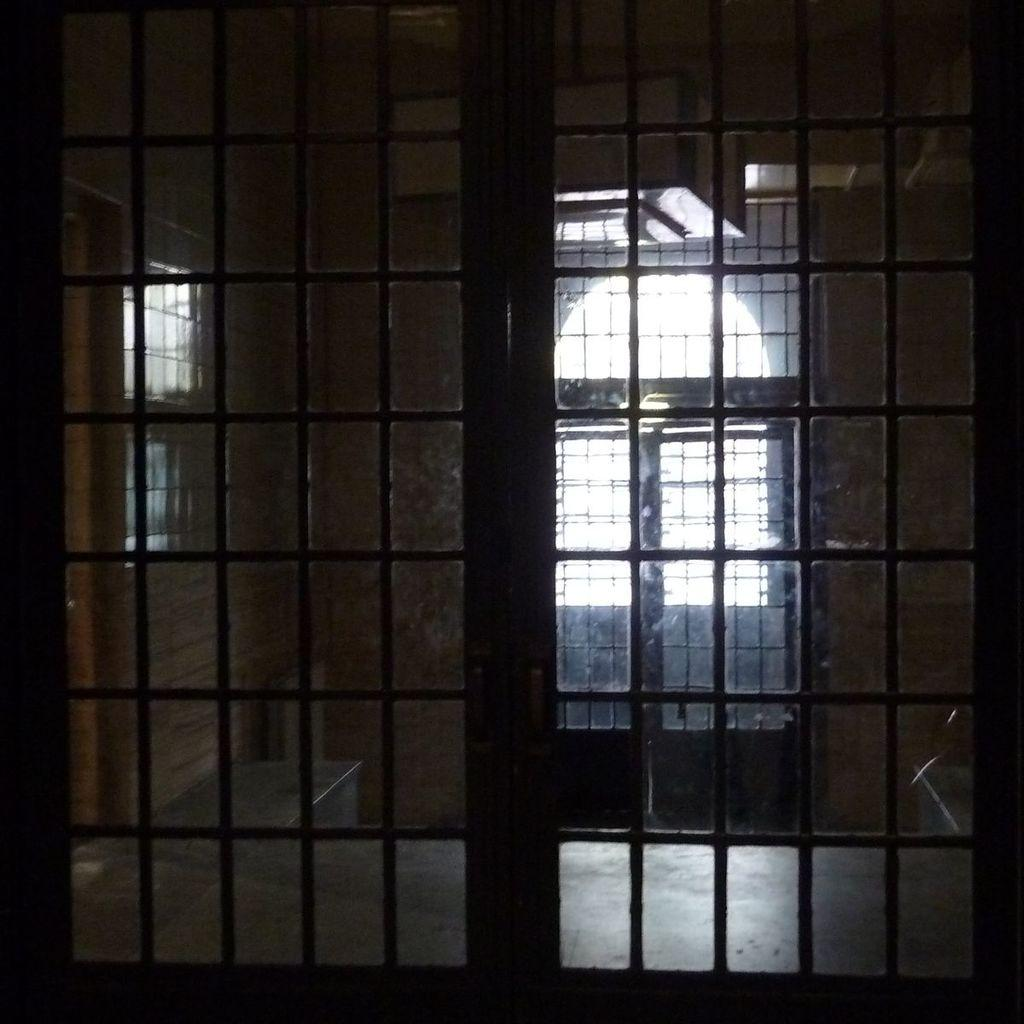What is present in the image that provides a view of the outside? There is a window in the image. What can be seen through the window in the image? The wall is visible through the window in the image. Can you see any jellyfish swimming in the image? There are no jellyfish present in the image. Is there a pig in the image creating harmony with the wall? There is no pig present in the image, and the image does not depict any concept of harmony. 